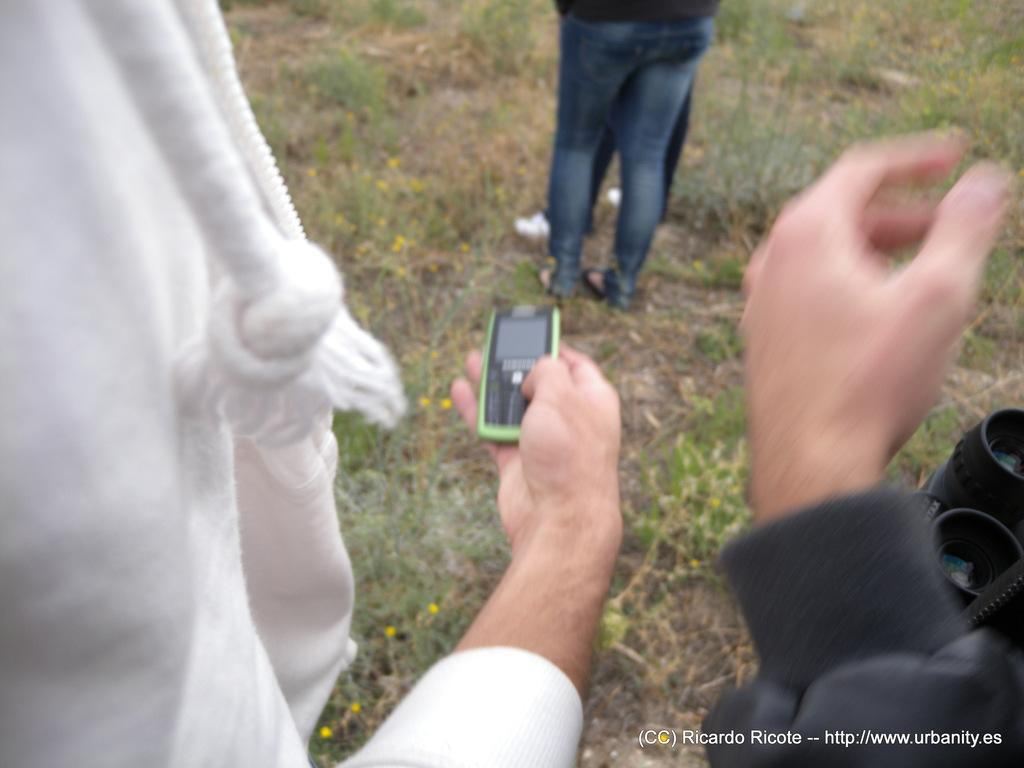What is happening in the middle of the image? There are many people standing in the middle of the image. What activity is someone performing in the image? Someone is operating a mobile in the image. What type of vegetation is present on the ground in the image? There are many grasses on the ground in the image. What type of brass instrument is being played by someone in the image? There is no brass instrument present in the image. What type of collar is visible on the people in the image? There is no mention of collars in the image, as the focus is on the people standing and someone operating a mobile. 